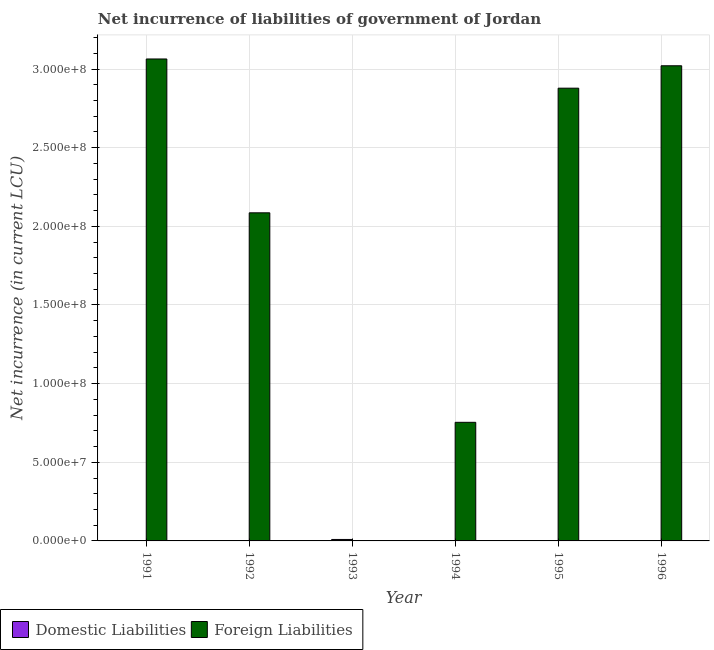How many bars are there on the 6th tick from the right?
Offer a very short reply. 1. What is the label of the 1st group of bars from the left?
Ensure brevity in your answer.  1991. In how many cases, is the number of bars for a given year not equal to the number of legend labels?
Offer a terse response. 6. What is the net incurrence of foreign liabilities in 1991?
Keep it short and to the point. 3.06e+08. Across all years, what is the maximum net incurrence of foreign liabilities?
Your answer should be compact. 3.06e+08. In which year was the net incurrence of foreign liabilities maximum?
Provide a short and direct response. 1991. What is the total net incurrence of foreign liabilities in the graph?
Offer a very short reply. 1.18e+09. What is the difference between the net incurrence of foreign liabilities in 1991 and that in 1994?
Offer a very short reply. 2.31e+08. What is the difference between the net incurrence of domestic liabilities in 1996 and the net incurrence of foreign liabilities in 1993?
Your answer should be very brief. -9.30e+05. What is the average net incurrence of domestic liabilities per year?
Give a very brief answer. 1.55e+05. In the year 1993, what is the difference between the net incurrence of domestic liabilities and net incurrence of foreign liabilities?
Offer a terse response. 0. In how many years, is the net incurrence of foreign liabilities greater than 290000000 LCU?
Your answer should be very brief. 2. What is the ratio of the net incurrence of foreign liabilities in 1995 to that in 1996?
Give a very brief answer. 0.95. Is the difference between the net incurrence of foreign liabilities in 1992 and 1994 greater than the difference between the net incurrence of domestic liabilities in 1992 and 1994?
Make the answer very short. No. What is the difference between the highest and the second highest net incurrence of foreign liabilities?
Provide a succinct answer. 4.32e+06. What is the difference between the highest and the lowest net incurrence of foreign liabilities?
Provide a succinct answer. 3.06e+08. In how many years, is the net incurrence of foreign liabilities greater than the average net incurrence of foreign liabilities taken over all years?
Make the answer very short. 4. How many bars are there?
Give a very brief answer. 6. Are all the bars in the graph horizontal?
Give a very brief answer. No. How many years are there in the graph?
Keep it short and to the point. 6. What is the difference between two consecutive major ticks on the Y-axis?
Offer a very short reply. 5.00e+07. Are the values on the major ticks of Y-axis written in scientific E-notation?
Provide a succinct answer. Yes. Does the graph contain any zero values?
Give a very brief answer. Yes. How many legend labels are there?
Offer a terse response. 2. How are the legend labels stacked?
Offer a terse response. Horizontal. What is the title of the graph?
Give a very brief answer. Net incurrence of liabilities of government of Jordan. Does "Highest 10% of population" appear as one of the legend labels in the graph?
Your response must be concise. No. What is the label or title of the Y-axis?
Provide a short and direct response. Net incurrence (in current LCU). What is the Net incurrence (in current LCU) in Domestic Liabilities in 1991?
Your response must be concise. 0. What is the Net incurrence (in current LCU) in Foreign Liabilities in 1991?
Your answer should be very brief. 3.06e+08. What is the Net incurrence (in current LCU) in Foreign Liabilities in 1992?
Your answer should be very brief. 2.09e+08. What is the Net incurrence (in current LCU) of Domestic Liabilities in 1993?
Your response must be concise. 9.30e+05. What is the Net incurrence (in current LCU) in Foreign Liabilities in 1993?
Ensure brevity in your answer.  0. What is the Net incurrence (in current LCU) of Foreign Liabilities in 1994?
Your response must be concise. 7.54e+07. What is the Net incurrence (in current LCU) in Domestic Liabilities in 1995?
Ensure brevity in your answer.  0. What is the Net incurrence (in current LCU) in Foreign Liabilities in 1995?
Offer a terse response. 2.88e+08. What is the Net incurrence (in current LCU) of Domestic Liabilities in 1996?
Keep it short and to the point. 0. What is the Net incurrence (in current LCU) of Foreign Liabilities in 1996?
Your answer should be very brief. 3.02e+08. Across all years, what is the maximum Net incurrence (in current LCU) of Domestic Liabilities?
Offer a very short reply. 9.30e+05. Across all years, what is the maximum Net incurrence (in current LCU) of Foreign Liabilities?
Offer a terse response. 3.06e+08. What is the total Net incurrence (in current LCU) of Domestic Liabilities in the graph?
Your answer should be compact. 9.30e+05. What is the total Net incurrence (in current LCU) in Foreign Liabilities in the graph?
Provide a succinct answer. 1.18e+09. What is the difference between the Net incurrence (in current LCU) in Foreign Liabilities in 1991 and that in 1992?
Offer a terse response. 9.78e+07. What is the difference between the Net incurrence (in current LCU) in Foreign Liabilities in 1991 and that in 1994?
Your answer should be compact. 2.31e+08. What is the difference between the Net incurrence (in current LCU) of Foreign Liabilities in 1991 and that in 1995?
Ensure brevity in your answer.  1.86e+07. What is the difference between the Net incurrence (in current LCU) of Foreign Liabilities in 1991 and that in 1996?
Keep it short and to the point. 4.32e+06. What is the difference between the Net incurrence (in current LCU) of Foreign Liabilities in 1992 and that in 1994?
Offer a terse response. 1.33e+08. What is the difference between the Net incurrence (in current LCU) of Foreign Liabilities in 1992 and that in 1995?
Your answer should be compact. -7.92e+07. What is the difference between the Net incurrence (in current LCU) in Foreign Liabilities in 1992 and that in 1996?
Your answer should be very brief. -9.35e+07. What is the difference between the Net incurrence (in current LCU) in Foreign Liabilities in 1994 and that in 1995?
Offer a terse response. -2.12e+08. What is the difference between the Net incurrence (in current LCU) in Foreign Liabilities in 1994 and that in 1996?
Your answer should be compact. -2.27e+08. What is the difference between the Net incurrence (in current LCU) in Foreign Liabilities in 1995 and that in 1996?
Provide a succinct answer. -1.42e+07. What is the difference between the Net incurrence (in current LCU) of Domestic Liabilities in 1993 and the Net incurrence (in current LCU) of Foreign Liabilities in 1994?
Offer a terse response. -7.45e+07. What is the difference between the Net incurrence (in current LCU) of Domestic Liabilities in 1993 and the Net incurrence (in current LCU) of Foreign Liabilities in 1995?
Offer a terse response. -2.87e+08. What is the difference between the Net incurrence (in current LCU) of Domestic Liabilities in 1993 and the Net incurrence (in current LCU) of Foreign Liabilities in 1996?
Your answer should be compact. -3.01e+08. What is the average Net incurrence (in current LCU) of Domestic Liabilities per year?
Provide a short and direct response. 1.55e+05. What is the average Net incurrence (in current LCU) in Foreign Liabilities per year?
Provide a short and direct response. 1.97e+08. What is the ratio of the Net incurrence (in current LCU) in Foreign Liabilities in 1991 to that in 1992?
Provide a succinct answer. 1.47. What is the ratio of the Net incurrence (in current LCU) in Foreign Liabilities in 1991 to that in 1994?
Provide a short and direct response. 4.06. What is the ratio of the Net incurrence (in current LCU) in Foreign Liabilities in 1991 to that in 1995?
Your answer should be very brief. 1.06. What is the ratio of the Net incurrence (in current LCU) of Foreign Liabilities in 1991 to that in 1996?
Keep it short and to the point. 1.01. What is the ratio of the Net incurrence (in current LCU) of Foreign Liabilities in 1992 to that in 1994?
Offer a terse response. 2.77. What is the ratio of the Net incurrence (in current LCU) of Foreign Liabilities in 1992 to that in 1995?
Ensure brevity in your answer.  0.72. What is the ratio of the Net incurrence (in current LCU) in Foreign Liabilities in 1992 to that in 1996?
Make the answer very short. 0.69. What is the ratio of the Net incurrence (in current LCU) in Foreign Liabilities in 1994 to that in 1995?
Keep it short and to the point. 0.26. What is the ratio of the Net incurrence (in current LCU) in Foreign Liabilities in 1994 to that in 1996?
Your response must be concise. 0.25. What is the ratio of the Net incurrence (in current LCU) of Foreign Liabilities in 1995 to that in 1996?
Your response must be concise. 0.95. What is the difference between the highest and the second highest Net incurrence (in current LCU) of Foreign Liabilities?
Offer a terse response. 4.32e+06. What is the difference between the highest and the lowest Net incurrence (in current LCU) of Domestic Liabilities?
Make the answer very short. 9.30e+05. What is the difference between the highest and the lowest Net incurrence (in current LCU) of Foreign Liabilities?
Provide a short and direct response. 3.06e+08. 